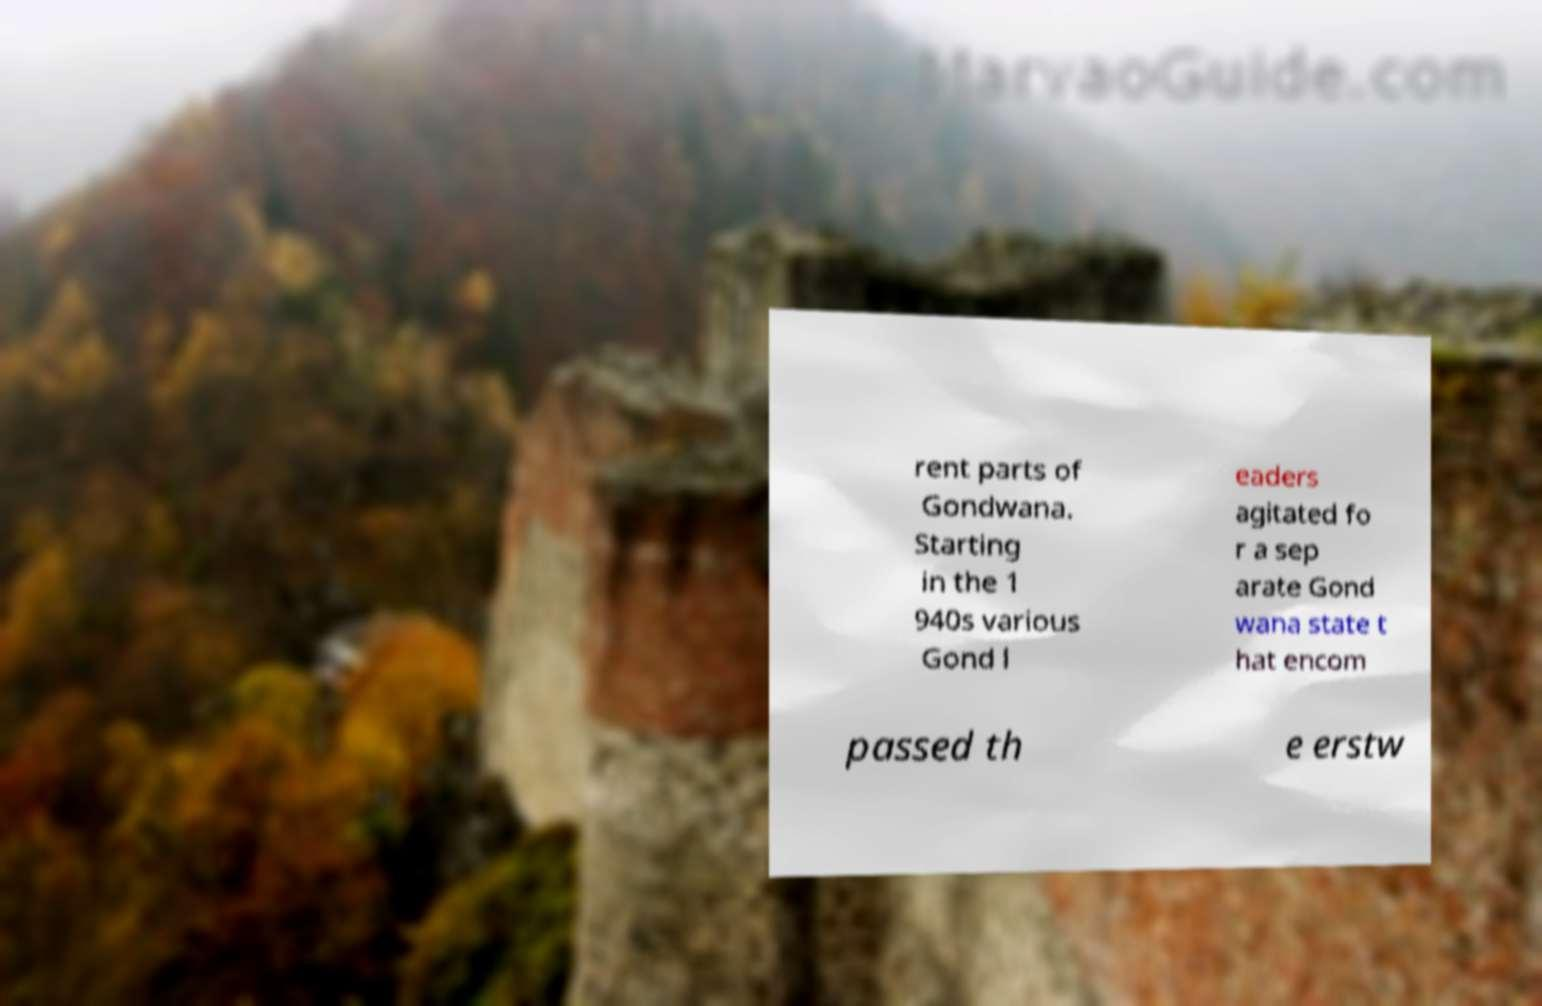Can you accurately transcribe the text from the provided image for me? rent parts of Gondwana. Starting in the 1 940s various Gond l eaders agitated fo r a sep arate Gond wana state t hat encom passed th e erstw 